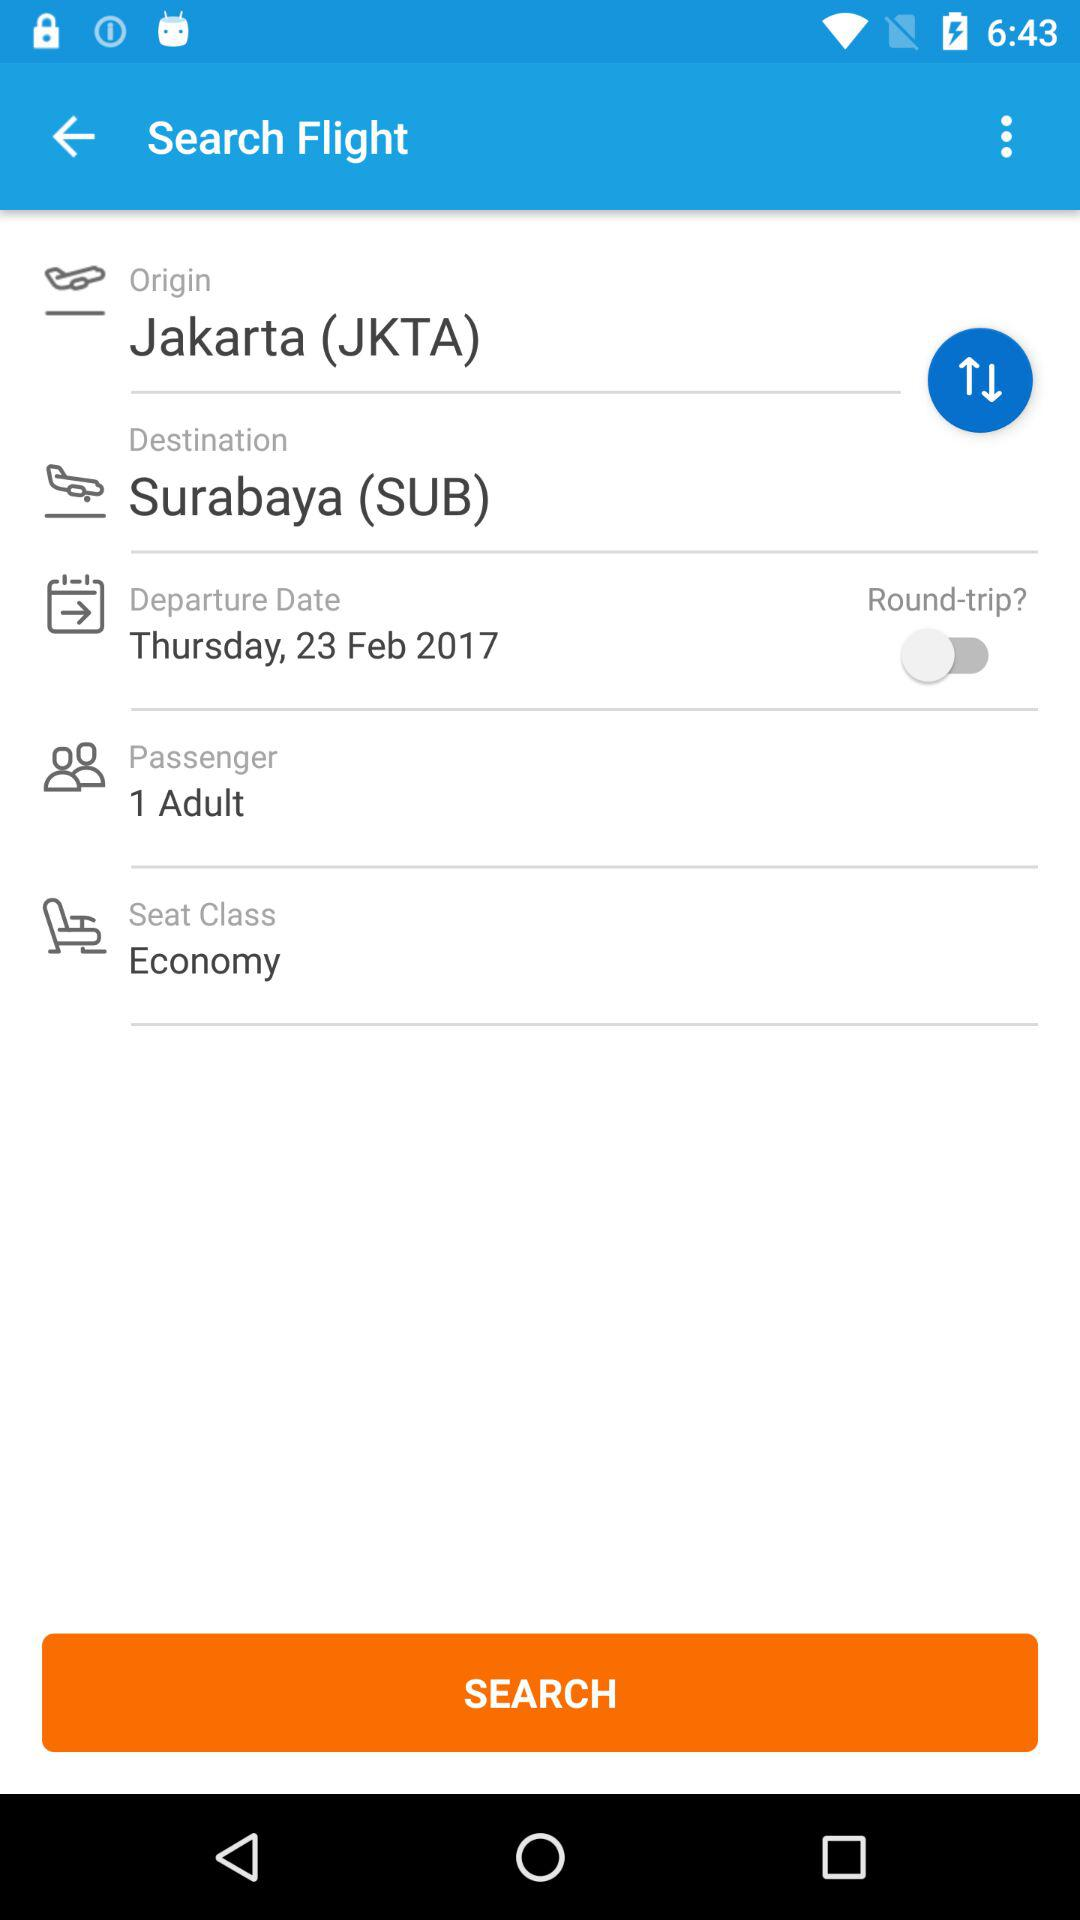How many adults are traveling?
Answer the question using a single word or phrase. 1 